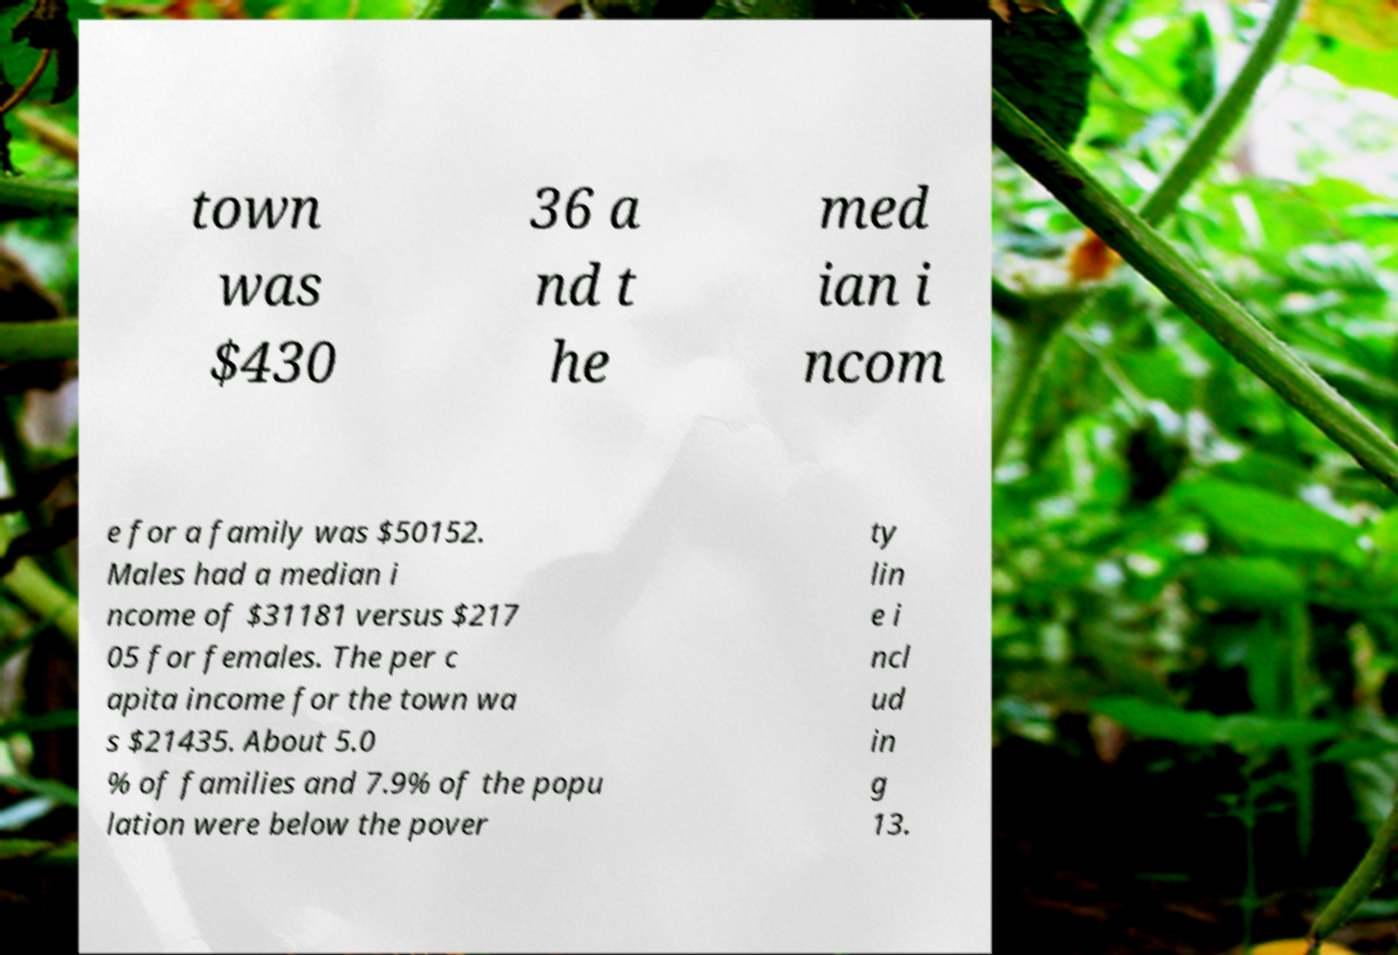Can you accurately transcribe the text from the provided image for me? town was $430 36 a nd t he med ian i ncom e for a family was $50152. Males had a median i ncome of $31181 versus $217 05 for females. The per c apita income for the town wa s $21435. About 5.0 % of families and 7.9% of the popu lation were below the pover ty lin e i ncl ud in g 13. 